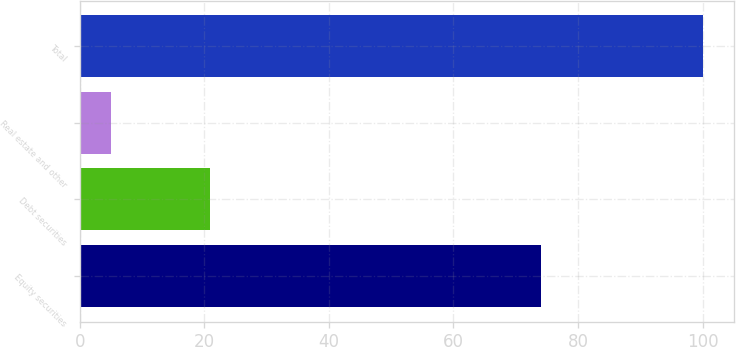Convert chart to OTSL. <chart><loc_0><loc_0><loc_500><loc_500><bar_chart><fcel>Equity securities<fcel>Debt securities<fcel>Real estate and other<fcel>Total<nl><fcel>74<fcel>21<fcel>5<fcel>100<nl></chart> 